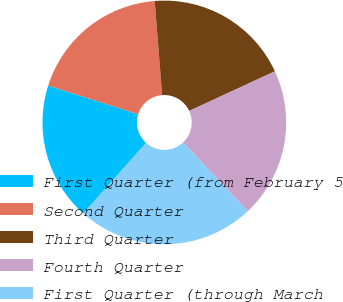Convert chart to OTSL. <chart><loc_0><loc_0><loc_500><loc_500><pie_chart><fcel>First Quarter (from February 5<fcel>Second Quarter<fcel>Third Quarter<fcel>Fourth Quarter<fcel>First Quarter (through March<nl><fcel>18.32%<fcel>18.85%<fcel>19.37%<fcel>19.89%<fcel>23.57%<nl></chart> 